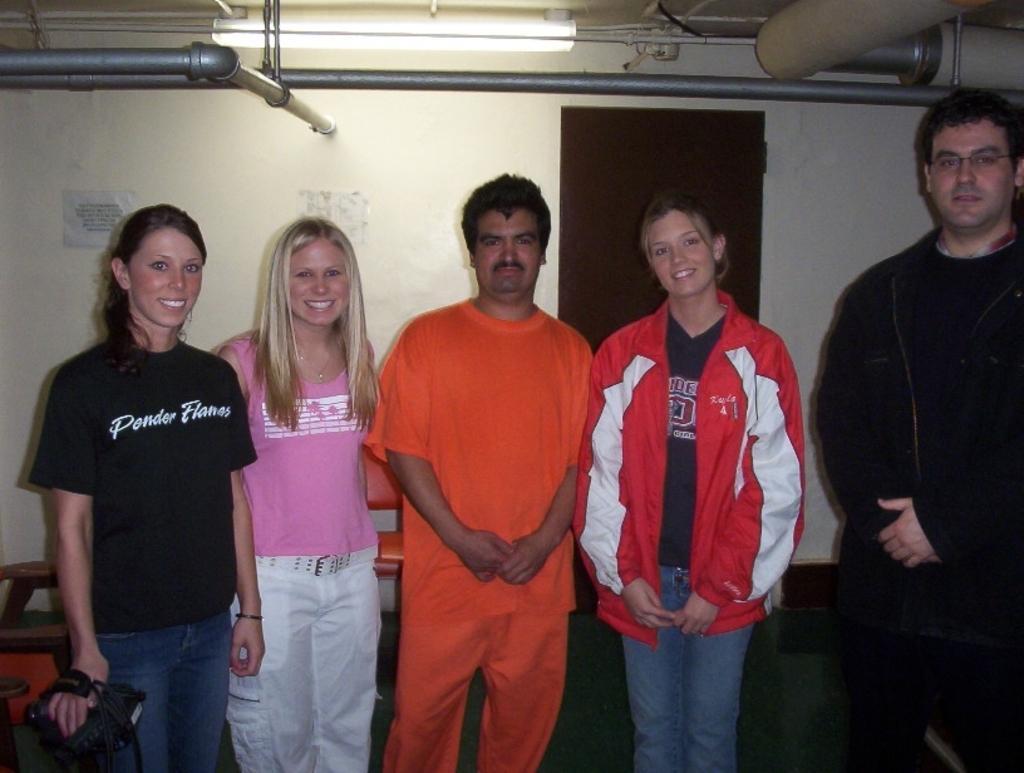Describe this image in one or two sentences. There are total five people three are women and two are men,all of them are posing for the photograph and the woman wearing black shirt is holding a camera,behind these people in the background there is a wall. 